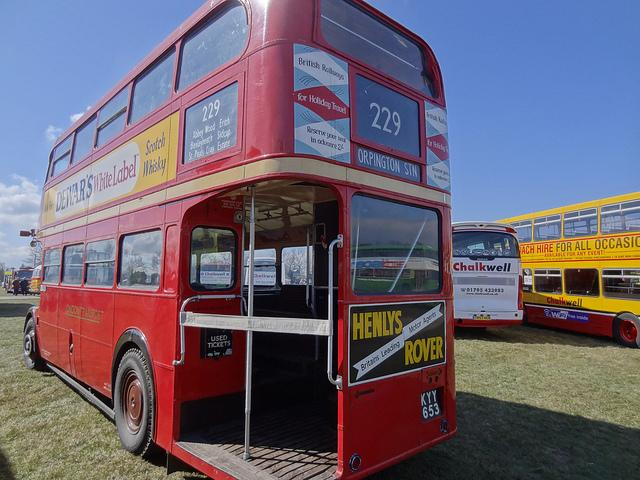What number is closest to the number at the top of the bus?

Choices:
A) 560
B) 803
C) 240
D) 121 240 